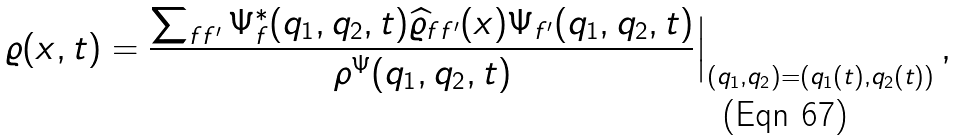<formula> <loc_0><loc_0><loc_500><loc_500>\varrho ( { x } , t ) = \frac { \sum _ { f f ^ { \prime } } \Psi ^ { * } _ { f } ( q _ { 1 } , q _ { 2 } , t ) { \widehat { \varrho } } _ { f f ^ { \prime } } ( { x } ) \Psi _ { f ^ { \prime } } ( q _ { 1 } , q _ { 2 } , t ) } { \rho ^ { \Psi } ( q _ { 1 } , q _ { 2 } , t ) } \Big | _ { ( q _ { 1 } , q _ { 2 } ) = ( q _ { 1 } ( t ) , q _ { 2 } ( t ) ) } \, ,</formula> 